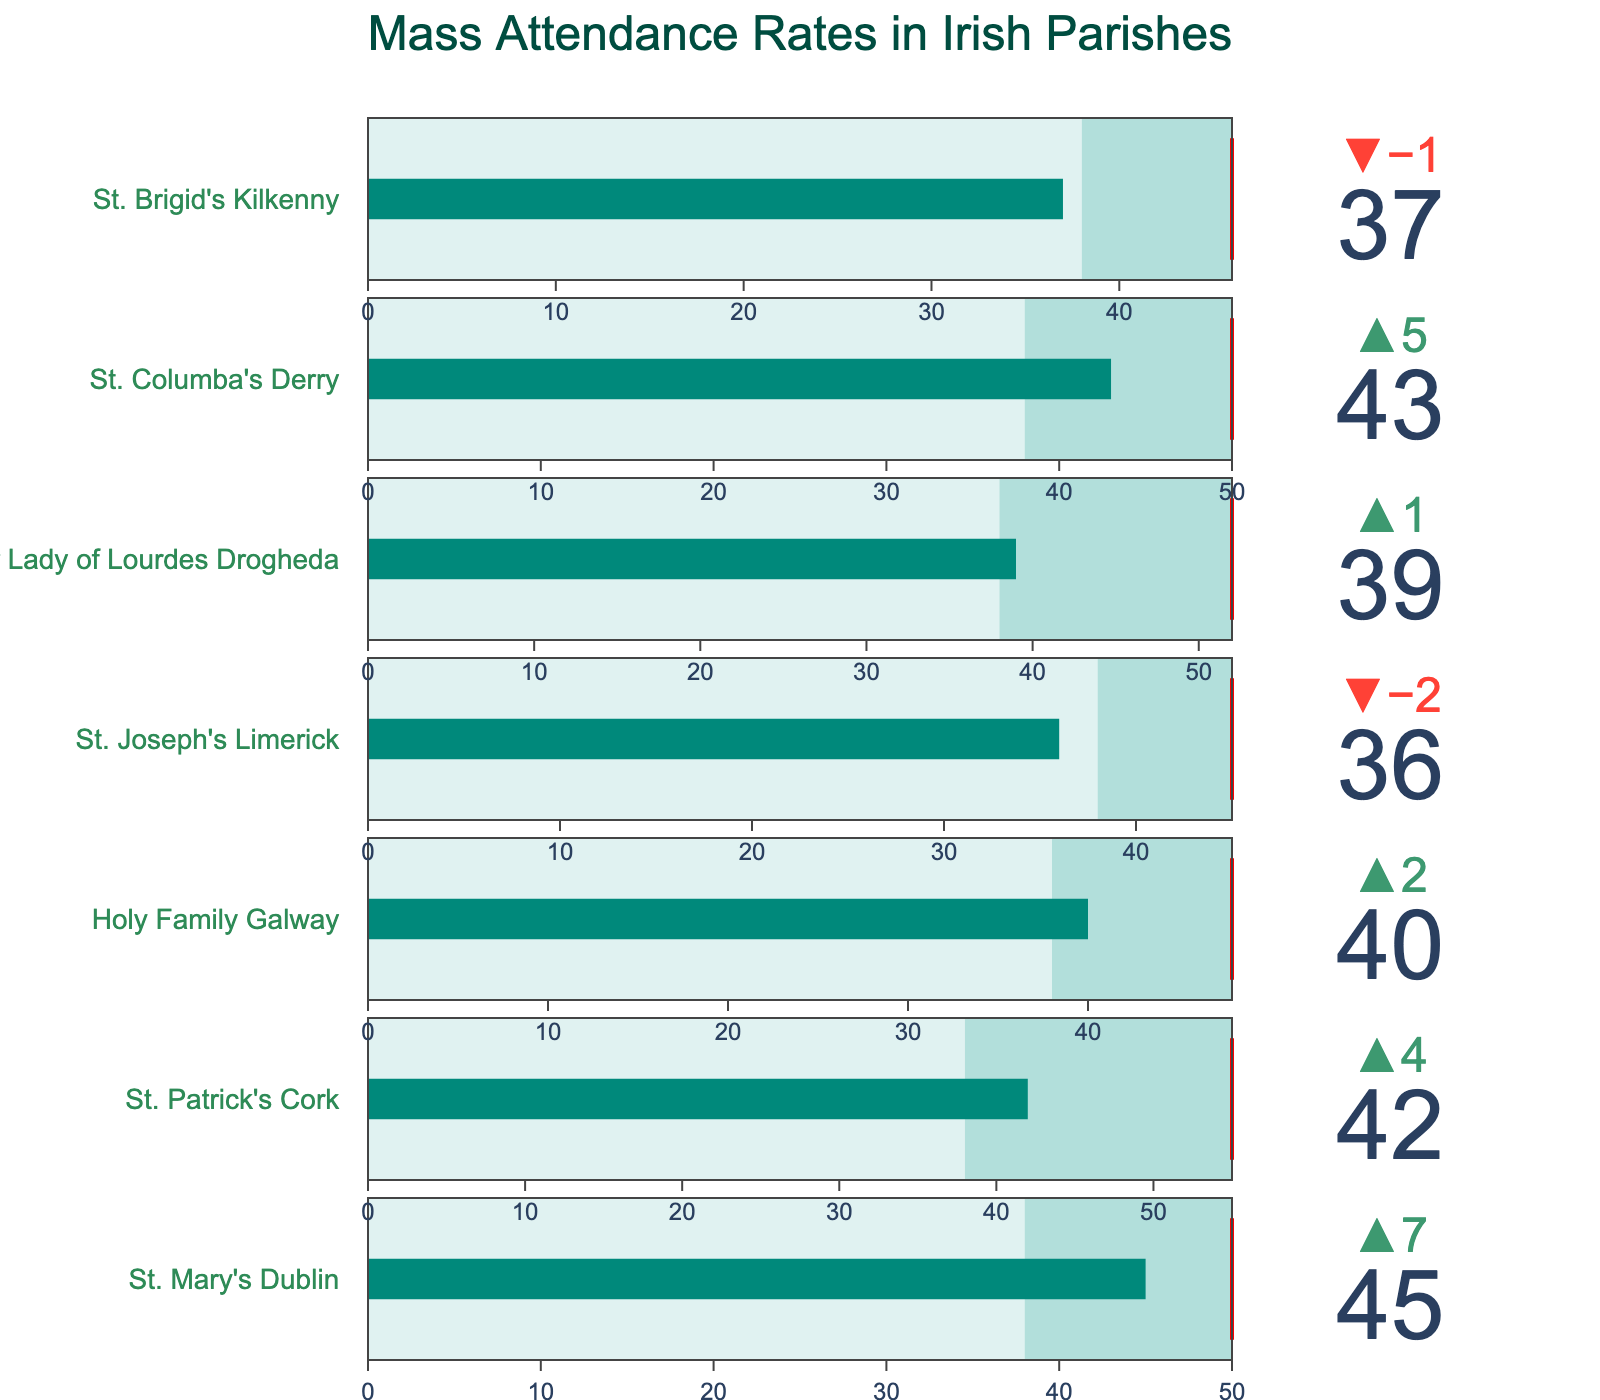What's the title of the figure? The title of the figure is prominently displayed at the top of the chart.
Answer: Mass Attendance Rates in Irish Parishes How many parishes are represented in the figure? There are a total of 7 different parishes listed in the figure, with each parish having its own section of the bullet chart.
Answer: 7 What parish has the highest actual mass attendance rate? By examining the bullet chart, the highest actual attendance rate is identified by looking at the 'Actual' value.
Answer: St. Mary's Dublin How does St. Joseph's Limerick compare to its target attendance rate? The bullet chart has a threshold line for the target. St. Joseph's Limerick has an actual rate of 36, a target of 45, and the target is unmet since 36 < 45.
Answer: Below target Which parish has the smallest difference between its actual and target attendance rate? To find the smallest difference, subtract each parish's actual rate from its target rate and compare the results. Holy Family Galway has the smallest difference (48 - 40 = 8).
Answer: Holy Family Galway Which parishes have an actual attendance rate higher than the national average? Compare the 'Actual' value to the 'Average' value for each parish. Parishes where 'Actual' > 'Average' are: St. Mary's Dublin (45 > 38), St. Patrick's Cork (42 > 38), Holy Family Galway (40 > 38), Our Lady of Lourdes Drogheda (39 > 38), and St. Columba's Derry (43 > 38).
Answer: Five parishes What is the average of the actual attendance rates across all parishes? Sum up all actual attendance rates and divide by the number of parishes: (45 + 42 + 40 + 36 + 39 + 43 + 37) / 7. This is: 282 / 7 = 40.286.
Answer: 40.286 Which parish has the largest positive delta compared to the national average? The delta is the difference between the actual attendance and the average. St. Mary's Dublin has the largest positive delta of +7 (45 - 38).
Answer: St. Mary's Dublin What is the range of values for the target attendance rates? The target rates can be seen from the bullet chart as the red lines. The range is found by identifying the minimum and maximum target values: min is 45, max is 55.
Answer: 45 to 55 